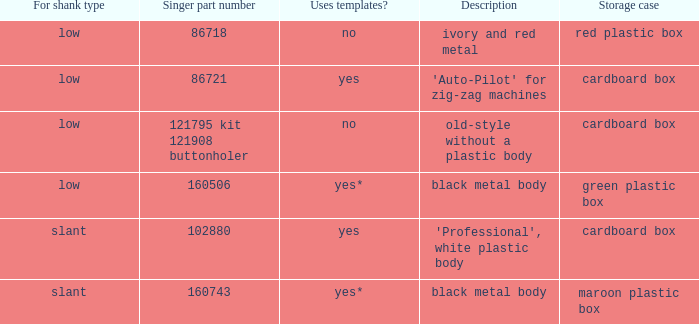What's the singer piece number of the buttonholer that comes with a green plastic storage box? 160506.0. Give me the full table as a dictionary. {'header': ['For shank type', 'Singer part number', 'Uses templates?', 'Description', 'Storage case'], 'rows': [['low', '86718', 'no', 'ivory and red metal', 'red plastic box'], ['low', '86721', 'yes', "'Auto-Pilot' for zig-zag machines", 'cardboard box'], ['low', '121795 kit 121908 buttonholer', 'no', 'old-style without a plastic body', 'cardboard box'], ['low', '160506', 'yes*', 'black metal body', 'green plastic box'], ['slant', '102880', 'yes', "'Professional', white plastic body", 'cardboard box'], ['slant', '160743', 'yes*', 'black metal body', 'maroon plastic box']]} 